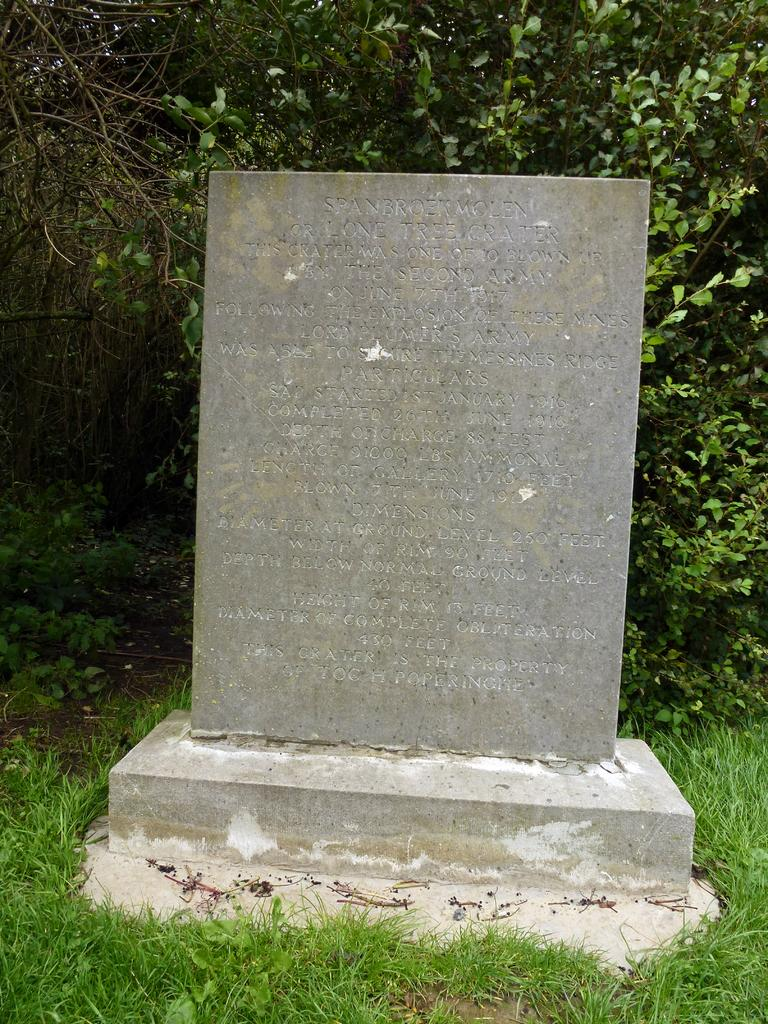What is the main subject on the platform in the image? There is a memorial on a platform in the image. How is the platform situated in relation to the ground? The platform is on the ground. What can be seen in the background of the image? There are trees, plants, and grass in the background of the image. What type of decision-making process is depicted in the image? There is no decision-making process depicted in the image; it features a memorial on a platform. Can you identify any representatives in the image? There are no representatives present in the image. 